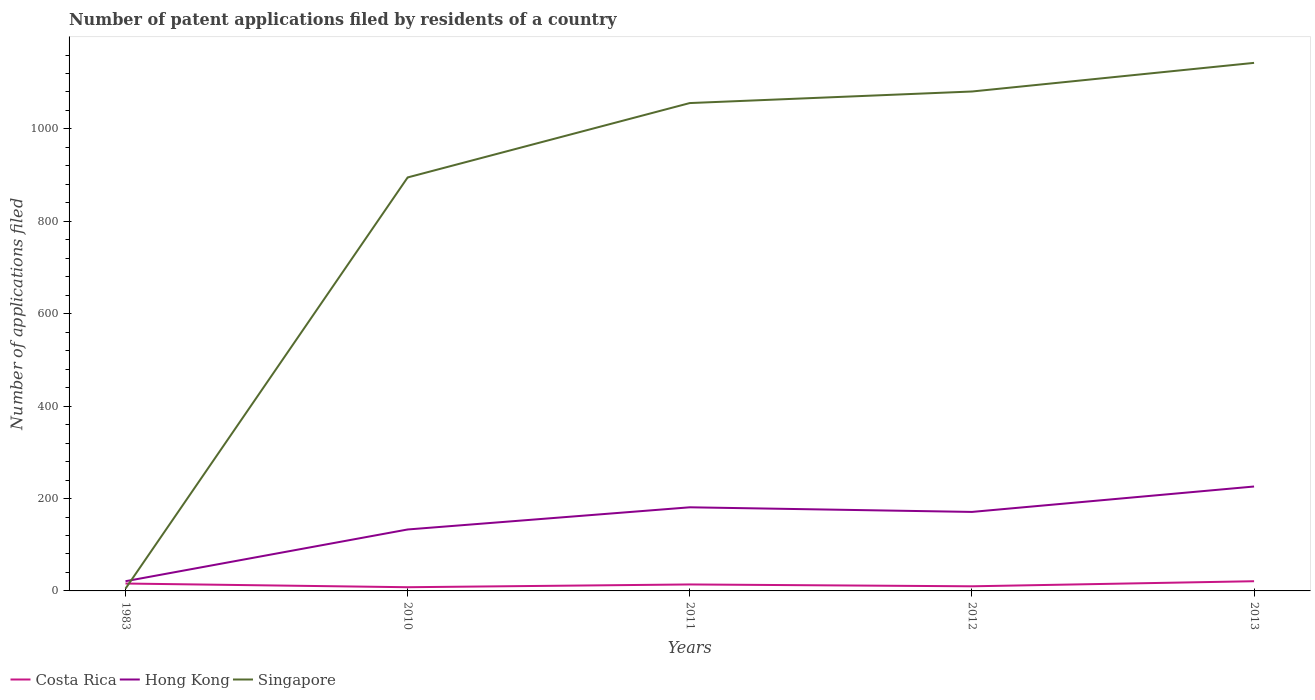How many different coloured lines are there?
Offer a very short reply. 3. What is the difference between the highest and the second highest number of applications filed in Hong Kong?
Give a very brief answer. 205. What is the difference between the highest and the lowest number of applications filed in Singapore?
Your response must be concise. 4. Is the number of applications filed in Singapore strictly greater than the number of applications filed in Costa Rica over the years?
Your response must be concise. No. How many lines are there?
Give a very brief answer. 3. What is the title of the graph?
Provide a short and direct response. Number of patent applications filed by residents of a country. What is the label or title of the X-axis?
Give a very brief answer. Years. What is the label or title of the Y-axis?
Offer a terse response. Number of applications filed. What is the Number of applications filed in Costa Rica in 1983?
Provide a short and direct response. 16. What is the Number of applications filed of Hong Kong in 1983?
Your answer should be very brief. 21. What is the Number of applications filed in Hong Kong in 2010?
Offer a very short reply. 133. What is the Number of applications filed in Singapore in 2010?
Give a very brief answer. 895. What is the Number of applications filed in Hong Kong in 2011?
Ensure brevity in your answer.  181. What is the Number of applications filed of Singapore in 2011?
Provide a succinct answer. 1056. What is the Number of applications filed in Hong Kong in 2012?
Ensure brevity in your answer.  171. What is the Number of applications filed in Singapore in 2012?
Your answer should be very brief. 1081. What is the Number of applications filed of Hong Kong in 2013?
Give a very brief answer. 226. What is the Number of applications filed in Singapore in 2013?
Ensure brevity in your answer.  1143. Across all years, what is the maximum Number of applications filed of Costa Rica?
Make the answer very short. 21. Across all years, what is the maximum Number of applications filed in Hong Kong?
Your response must be concise. 226. Across all years, what is the maximum Number of applications filed of Singapore?
Provide a short and direct response. 1143. Across all years, what is the minimum Number of applications filed in Costa Rica?
Your answer should be very brief. 8. Across all years, what is the minimum Number of applications filed in Hong Kong?
Your answer should be very brief. 21. What is the total Number of applications filed in Hong Kong in the graph?
Your response must be concise. 732. What is the total Number of applications filed of Singapore in the graph?
Make the answer very short. 4180. What is the difference between the Number of applications filed of Hong Kong in 1983 and that in 2010?
Make the answer very short. -112. What is the difference between the Number of applications filed of Singapore in 1983 and that in 2010?
Provide a short and direct response. -890. What is the difference between the Number of applications filed in Costa Rica in 1983 and that in 2011?
Your answer should be very brief. 2. What is the difference between the Number of applications filed of Hong Kong in 1983 and that in 2011?
Offer a terse response. -160. What is the difference between the Number of applications filed of Singapore in 1983 and that in 2011?
Your answer should be very brief. -1051. What is the difference between the Number of applications filed in Costa Rica in 1983 and that in 2012?
Ensure brevity in your answer.  6. What is the difference between the Number of applications filed of Hong Kong in 1983 and that in 2012?
Offer a terse response. -150. What is the difference between the Number of applications filed of Singapore in 1983 and that in 2012?
Provide a succinct answer. -1076. What is the difference between the Number of applications filed of Costa Rica in 1983 and that in 2013?
Your answer should be compact. -5. What is the difference between the Number of applications filed in Hong Kong in 1983 and that in 2013?
Ensure brevity in your answer.  -205. What is the difference between the Number of applications filed in Singapore in 1983 and that in 2013?
Offer a very short reply. -1138. What is the difference between the Number of applications filed of Hong Kong in 2010 and that in 2011?
Keep it short and to the point. -48. What is the difference between the Number of applications filed of Singapore in 2010 and that in 2011?
Give a very brief answer. -161. What is the difference between the Number of applications filed of Hong Kong in 2010 and that in 2012?
Provide a short and direct response. -38. What is the difference between the Number of applications filed of Singapore in 2010 and that in 2012?
Your answer should be very brief. -186. What is the difference between the Number of applications filed in Costa Rica in 2010 and that in 2013?
Your answer should be compact. -13. What is the difference between the Number of applications filed in Hong Kong in 2010 and that in 2013?
Your answer should be very brief. -93. What is the difference between the Number of applications filed in Singapore in 2010 and that in 2013?
Offer a very short reply. -248. What is the difference between the Number of applications filed in Costa Rica in 2011 and that in 2012?
Your response must be concise. 4. What is the difference between the Number of applications filed of Hong Kong in 2011 and that in 2012?
Offer a terse response. 10. What is the difference between the Number of applications filed of Singapore in 2011 and that in 2012?
Give a very brief answer. -25. What is the difference between the Number of applications filed of Costa Rica in 2011 and that in 2013?
Offer a very short reply. -7. What is the difference between the Number of applications filed in Hong Kong in 2011 and that in 2013?
Offer a very short reply. -45. What is the difference between the Number of applications filed of Singapore in 2011 and that in 2013?
Provide a succinct answer. -87. What is the difference between the Number of applications filed in Costa Rica in 2012 and that in 2013?
Make the answer very short. -11. What is the difference between the Number of applications filed of Hong Kong in 2012 and that in 2013?
Your response must be concise. -55. What is the difference between the Number of applications filed of Singapore in 2012 and that in 2013?
Provide a short and direct response. -62. What is the difference between the Number of applications filed of Costa Rica in 1983 and the Number of applications filed of Hong Kong in 2010?
Offer a very short reply. -117. What is the difference between the Number of applications filed in Costa Rica in 1983 and the Number of applications filed in Singapore in 2010?
Your response must be concise. -879. What is the difference between the Number of applications filed in Hong Kong in 1983 and the Number of applications filed in Singapore in 2010?
Offer a terse response. -874. What is the difference between the Number of applications filed in Costa Rica in 1983 and the Number of applications filed in Hong Kong in 2011?
Keep it short and to the point. -165. What is the difference between the Number of applications filed of Costa Rica in 1983 and the Number of applications filed of Singapore in 2011?
Your answer should be compact. -1040. What is the difference between the Number of applications filed in Hong Kong in 1983 and the Number of applications filed in Singapore in 2011?
Your response must be concise. -1035. What is the difference between the Number of applications filed in Costa Rica in 1983 and the Number of applications filed in Hong Kong in 2012?
Your answer should be compact. -155. What is the difference between the Number of applications filed in Costa Rica in 1983 and the Number of applications filed in Singapore in 2012?
Provide a succinct answer. -1065. What is the difference between the Number of applications filed in Hong Kong in 1983 and the Number of applications filed in Singapore in 2012?
Make the answer very short. -1060. What is the difference between the Number of applications filed in Costa Rica in 1983 and the Number of applications filed in Hong Kong in 2013?
Give a very brief answer. -210. What is the difference between the Number of applications filed of Costa Rica in 1983 and the Number of applications filed of Singapore in 2013?
Your answer should be compact. -1127. What is the difference between the Number of applications filed of Hong Kong in 1983 and the Number of applications filed of Singapore in 2013?
Provide a short and direct response. -1122. What is the difference between the Number of applications filed of Costa Rica in 2010 and the Number of applications filed of Hong Kong in 2011?
Make the answer very short. -173. What is the difference between the Number of applications filed in Costa Rica in 2010 and the Number of applications filed in Singapore in 2011?
Your response must be concise. -1048. What is the difference between the Number of applications filed in Hong Kong in 2010 and the Number of applications filed in Singapore in 2011?
Offer a very short reply. -923. What is the difference between the Number of applications filed in Costa Rica in 2010 and the Number of applications filed in Hong Kong in 2012?
Provide a succinct answer. -163. What is the difference between the Number of applications filed in Costa Rica in 2010 and the Number of applications filed in Singapore in 2012?
Provide a short and direct response. -1073. What is the difference between the Number of applications filed of Hong Kong in 2010 and the Number of applications filed of Singapore in 2012?
Your answer should be compact. -948. What is the difference between the Number of applications filed of Costa Rica in 2010 and the Number of applications filed of Hong Kong in 2013?
Keep it short and to the point. -218. What is the difference between the Number of applications filed of Costa Rica in 2010 and the Number of applications filed of Singapore in 2013?
Ensure brevity in your answer.  -1135. What is the difference between the Number of applications filed in Hong Kong in 2010 and the Number of applications filed in Singapore in 2013?
Your answer should be compact. -1010. What is the difference between the Number of applications filed of Costa Rica in 2011 and the Number of applications filed of Hong Kong in 2012?
Your answer should be very brief. -157. What is the difference between the Number of applications filed of Costa Rica in 2011 and the Number of applications filed of Singapore in 2012?
Offer a terse response. -1067. What is the difference between the Number of applications filed of Hong Kong in 2011 and the Number of applications filed of Singapore in 2012?
Make the answer very short. -900. What is the difference between the Number of applications filed in Costa Rica in 2011 and the Number of applications filed in Hong Kong in 2013?
Provide a succinct answer. -212. What is the difference between the Number of applications filed in Costa Rica in 2011 and the Number of applications filed in Singapore in 2013?
Your answer should be compact. -1129. What is the difference between the Number of applications filed in Hong Kong in 2011 and the Number of applications filed in Singapore in 2013?
Your answer should be very brief. -962. What is the difference between the Number of applications filed in Costa Rica in 2012 and the Number of applications filed in Hong Kong in 2013?
Provide a succinct answer. -216. What is the difference between the Number of applications filed in Costa Rica in 2012 and the Number of applications filed in Singapore in 2013?
Give a very brief answer. -1133. What is the difference between the Number of applications filed of Hong Kong in 2012 and the Number of applications filed of Singapore in 2013?
Provide a succinct answer. -972. What is the average Number of applications filed of Costa Rica per year?
Make the answer very short. 13.8. What is the average Number of applications filed in Hong Kong per year?
Your answer should be compact. 146.4. What is the average Number of applications filed in Singapore per year?
Offer a very short reply. 836. In the year 1983, what is the difference between the Number of applications filed in Costa Rica and Number of applications filed in Hong Kong?
Provide a short and direct response. -5. In the year 2010, what is the difference between the Number of applications filed in Costa Rica and Number of applications filed in Hong Kong?
Offer a very short reply. -125. In the year 2010, what is the difference between the Number of applications filed in Costa Rica and Number of applications filed in Singapore?
Your response must be concise. -887. In the year 2010, what is the difference between the Number of applications filed in Hong Kong and Number of applications filed in Singapore?
Offer a very short reply. -762. In the year 2011, what is the difference between the Number of applications filed in Costa Rica and Number of applications filed in Hong Kong?
Ensure brevity in your answer.  -167. In the year 2011, what is the difference between the Number of applications filed of Costa Rica and Number of applications filed of Singapore?
Your answer should be very brief. -1042. In the year 2011, what is the difference between the Number of applications filed in Hong Kong and Number of applications filed in Singapore?
Offer a terse response. -875. In the year 2012, what is the difference between the Number of applications filed in Costa Rica and Number of applications filed in Hong Kong?
Offer a terse response. -161. In the year 2012, what is the difference between the Number of applications filed of Costa Rica and Number of applications filed of Singapore?
Give a very brief answer. -1071. In the year 2012, what is the difference between the Number of applications filed of Hong Kong and Number of applications filed of Singapore?
Keep it short and to the point. -910. In the year 2013, what is the difference between the Number of applications filed in Costa Rica and Number of applications filed in Hong Kong?
Make the answer very short. -205. In the year 2013, what is the difference between the Number of applications filed of Costa Rica and Number of applications filed of Singapore?
Offer a terse response. -1122. In the year 2013, what is the difference between the Number of applications filed of Hong Kong and Number of applications filed of Singapore?
Offer a very short reply. -917. What is the ratio of the Number of applications filed in Costa Rica in 1983 to that in 2010?
Offer a terse response. 2. What is the ratio of the Number of applications filed of Hong Kong in 1983 to that in 2010?
Your answer should be very brief. 0.16. What is the ratio of the Number of applications filed of Singapore in 1983 to that in 2010?
Give a very brief answer. 0.01. What is the ratio of the Number of applications filed of Hong Kong in 1983 to that in 2011?
Offer a very short reply. 0.12. What is the ratio of the Number of applications filed of Singapore in 1983 to that in 2011?
Offer a terse response. 0. What is the ratio of the Number of applications filed of Costa Rica in 1983 to that in 2012?
Offer a terse response. 1.6. What is the ratio of the Number of applications filed in Hong Kong in 1983 to that in 2012?
Ensure brevity in your answer.  0.12. What is the ratio of the Number of applications filed of Singapore in 1983 to that in 2012?
Provide a short and direct response. 0. What is the ratio of the Number of applications filed of Costa Rica in 1983 to that in 2013?
Ensure brevity in your answer.  0.76. What is the ratio of the Number of applications filed in Hong Kong in 1983 to that in 2013?
Offer a terse response. 0.09. What is the ratio of the Number of applications filed of Singapore in 1983 to that in 2013?
Give a very brief answer. 0. What is the ratio of the Number of applications filed in Costa Rica in 2010 to that in 2011?
Your answer should be very brief. 0.57. What is the ratio of the Number of applications filed in Hong Kong in 2010 to that in 2011?
Give a very brief answer. 0.73. What is the ratio of the Number of applications filed in Singapore in 2010 to that in 2011?
Offer a very short reply. 0.85. What is the ratio of the Number of applications filed of Singapore in 2010 to that in 2012?
Make the answer very short. 0.83. What is the ratio of the Number of applications filed of Costa Rica in 2010 to that in 2013?
Offer a very short reply. 0.38. What is the ratio of the Number of applications filed of Hong Kong in 2010 to that in 2013?
Offer a terse response. 0.59. What is the ratio of the Number of applications filed of Singapore in 2010 to that in 2013?
Make the answer very short. 0.78. What is the ratio of the Number of applications filed in Costa Rica in 2011 to that in 2012?
Keep it short and to the point. 1.4. What is the ratio of the Number of applications filed in Hong Kong in 2011 to that in 2012?
Your answer should be very brief. 1.06. What is the ratio of the Number of applications filed of Singapore in 2011 to that in 2012?
Keep it short and to the point. 0.98. What is the ratio of the Number of applications filed of Hong Kong in 2011 to that in 2013?
Ensure brevity in your answer.  0.8. What is the ratio of the Number of applications filed of Singapore in 2011 to that in 2013?
Offer a very short reply. 0.92. What is the ratio of the Number of applications filed of Costa Rica in 2012 to that in 2013?
Ensure brevity in your answer.  0.48. What is the ratio of the Number of applications filed in Hong Kong in 2012 to that in 2013?
Your answer should be very brief. 0.76. What is the ratio of the Number of applications filed of Singapore in 2012 to that in 2013?
Keep it short and to the point. 0.95. What is the difference between the highest and the second highest Number of applications filed of Costa Rica?
Ensure brevity in your answer.  5. What is the difference between the highest and the second highest Number of applications filed in Hong Kong?
Keep it short and to the point. 45. What is the difference between the highest and the second highest Number of applications filed in Singapore?
Make the answer very short. 62. What is the difference between the highest and the lowest Number of applications filed of Hong Kong?
Provide a short and direct response. 205. What is the difference between the highest and the lowest Number of applications filed in Singapore?
Offer a terse response. 1138. 